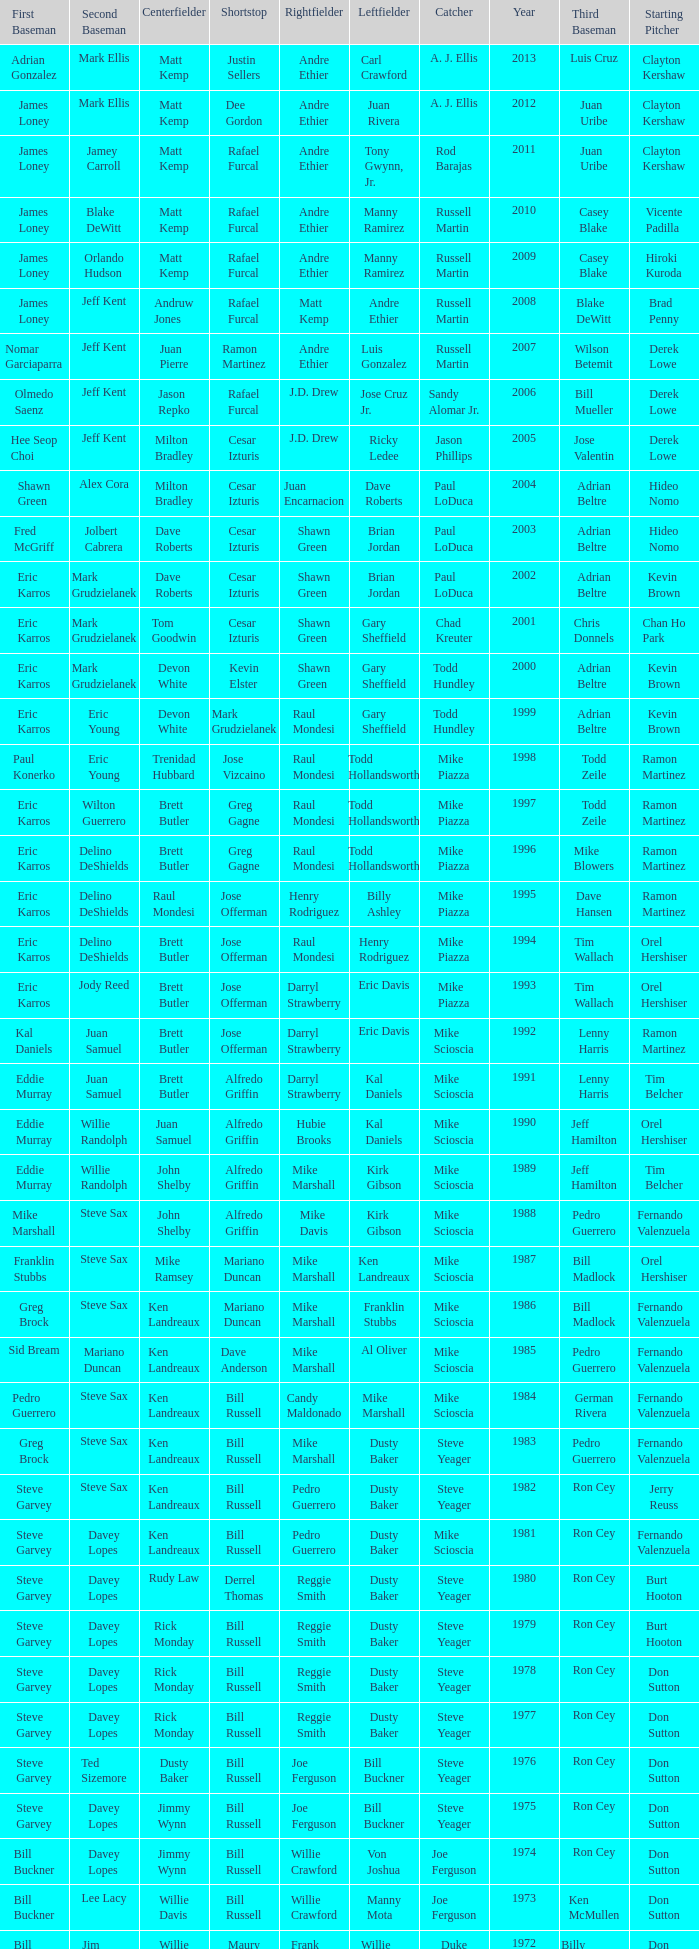Who played SS when paul konerko played 1st base? Jose Vizcaino. 